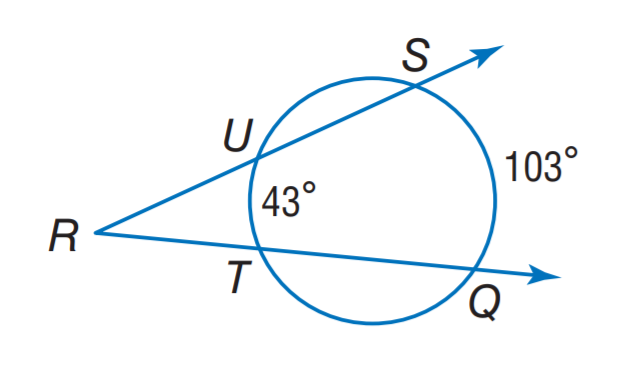Question: Find m \angle R.
Choices:
A. 13
B. 30
C. 43
D. 77
Answer with the letter. Answer: B 